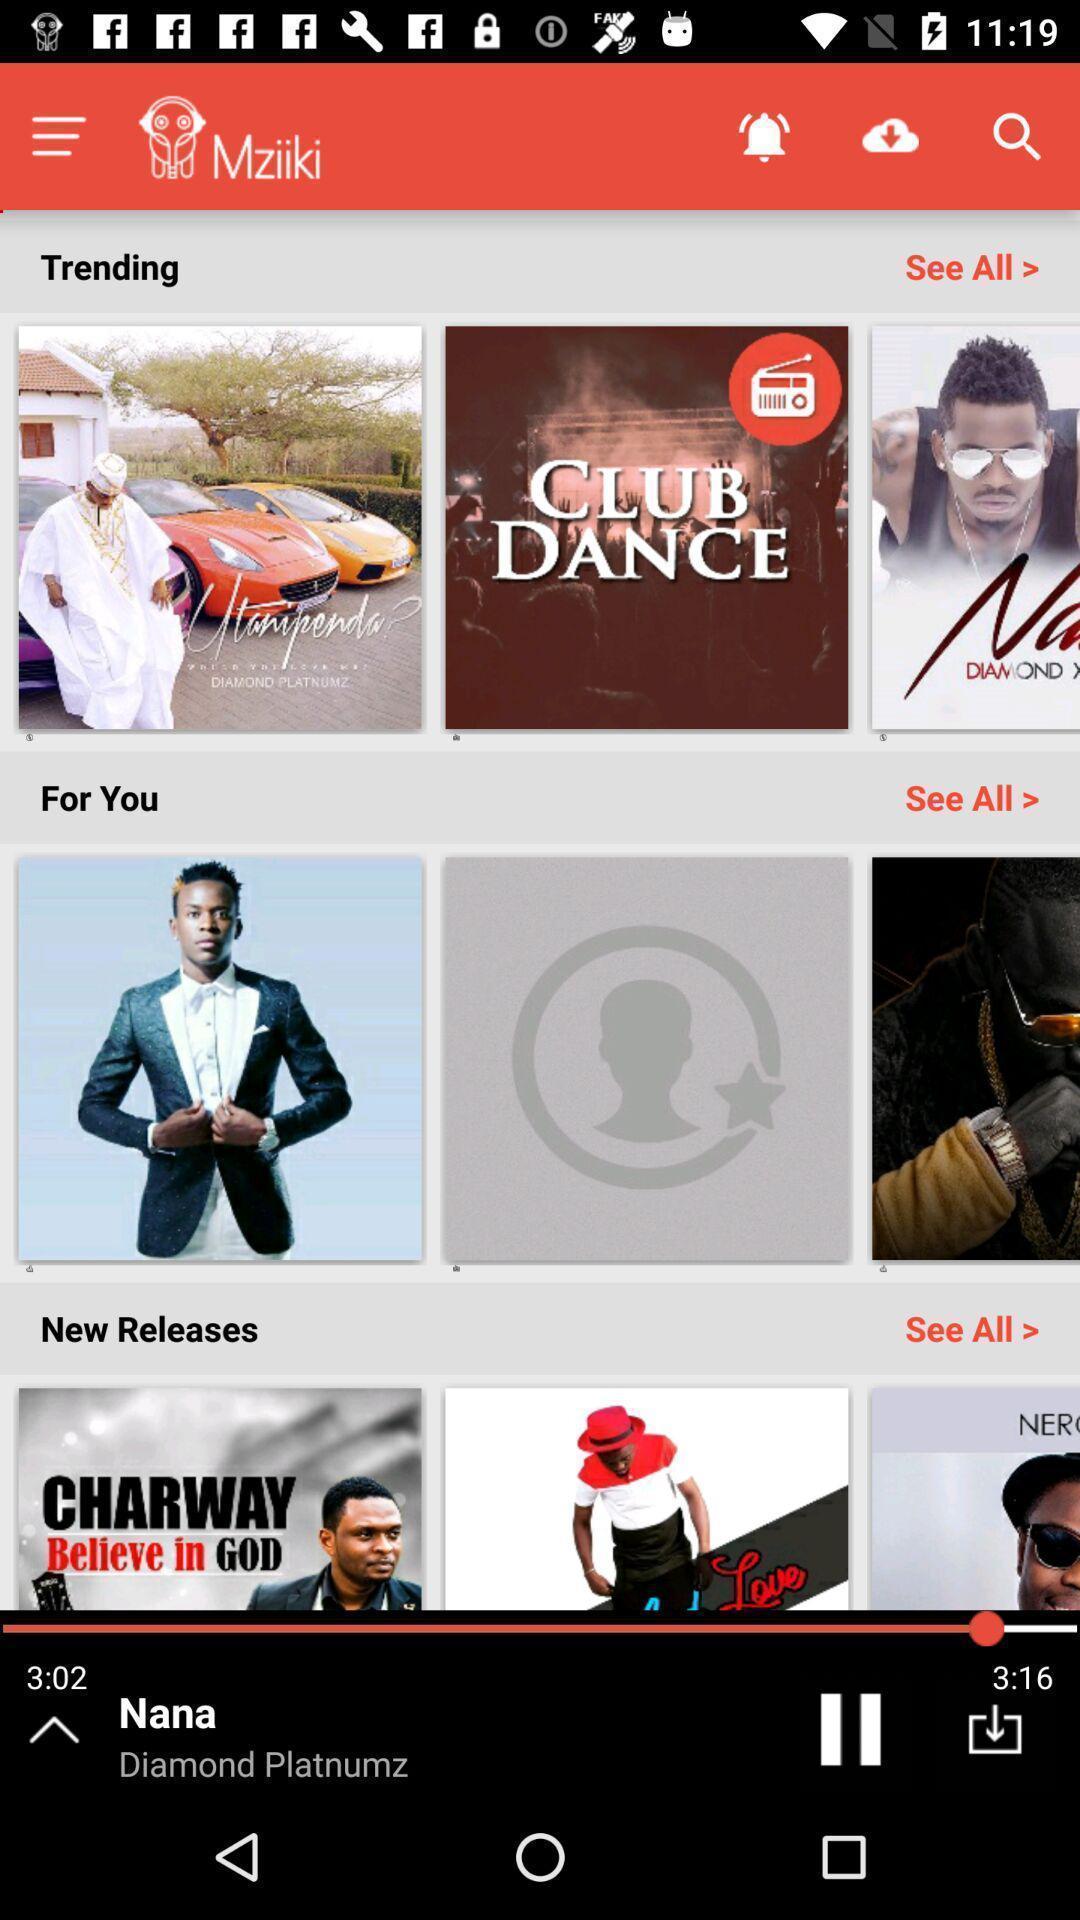Provide a description of this screenshot. Screen shows trending list of a music streaming app. 